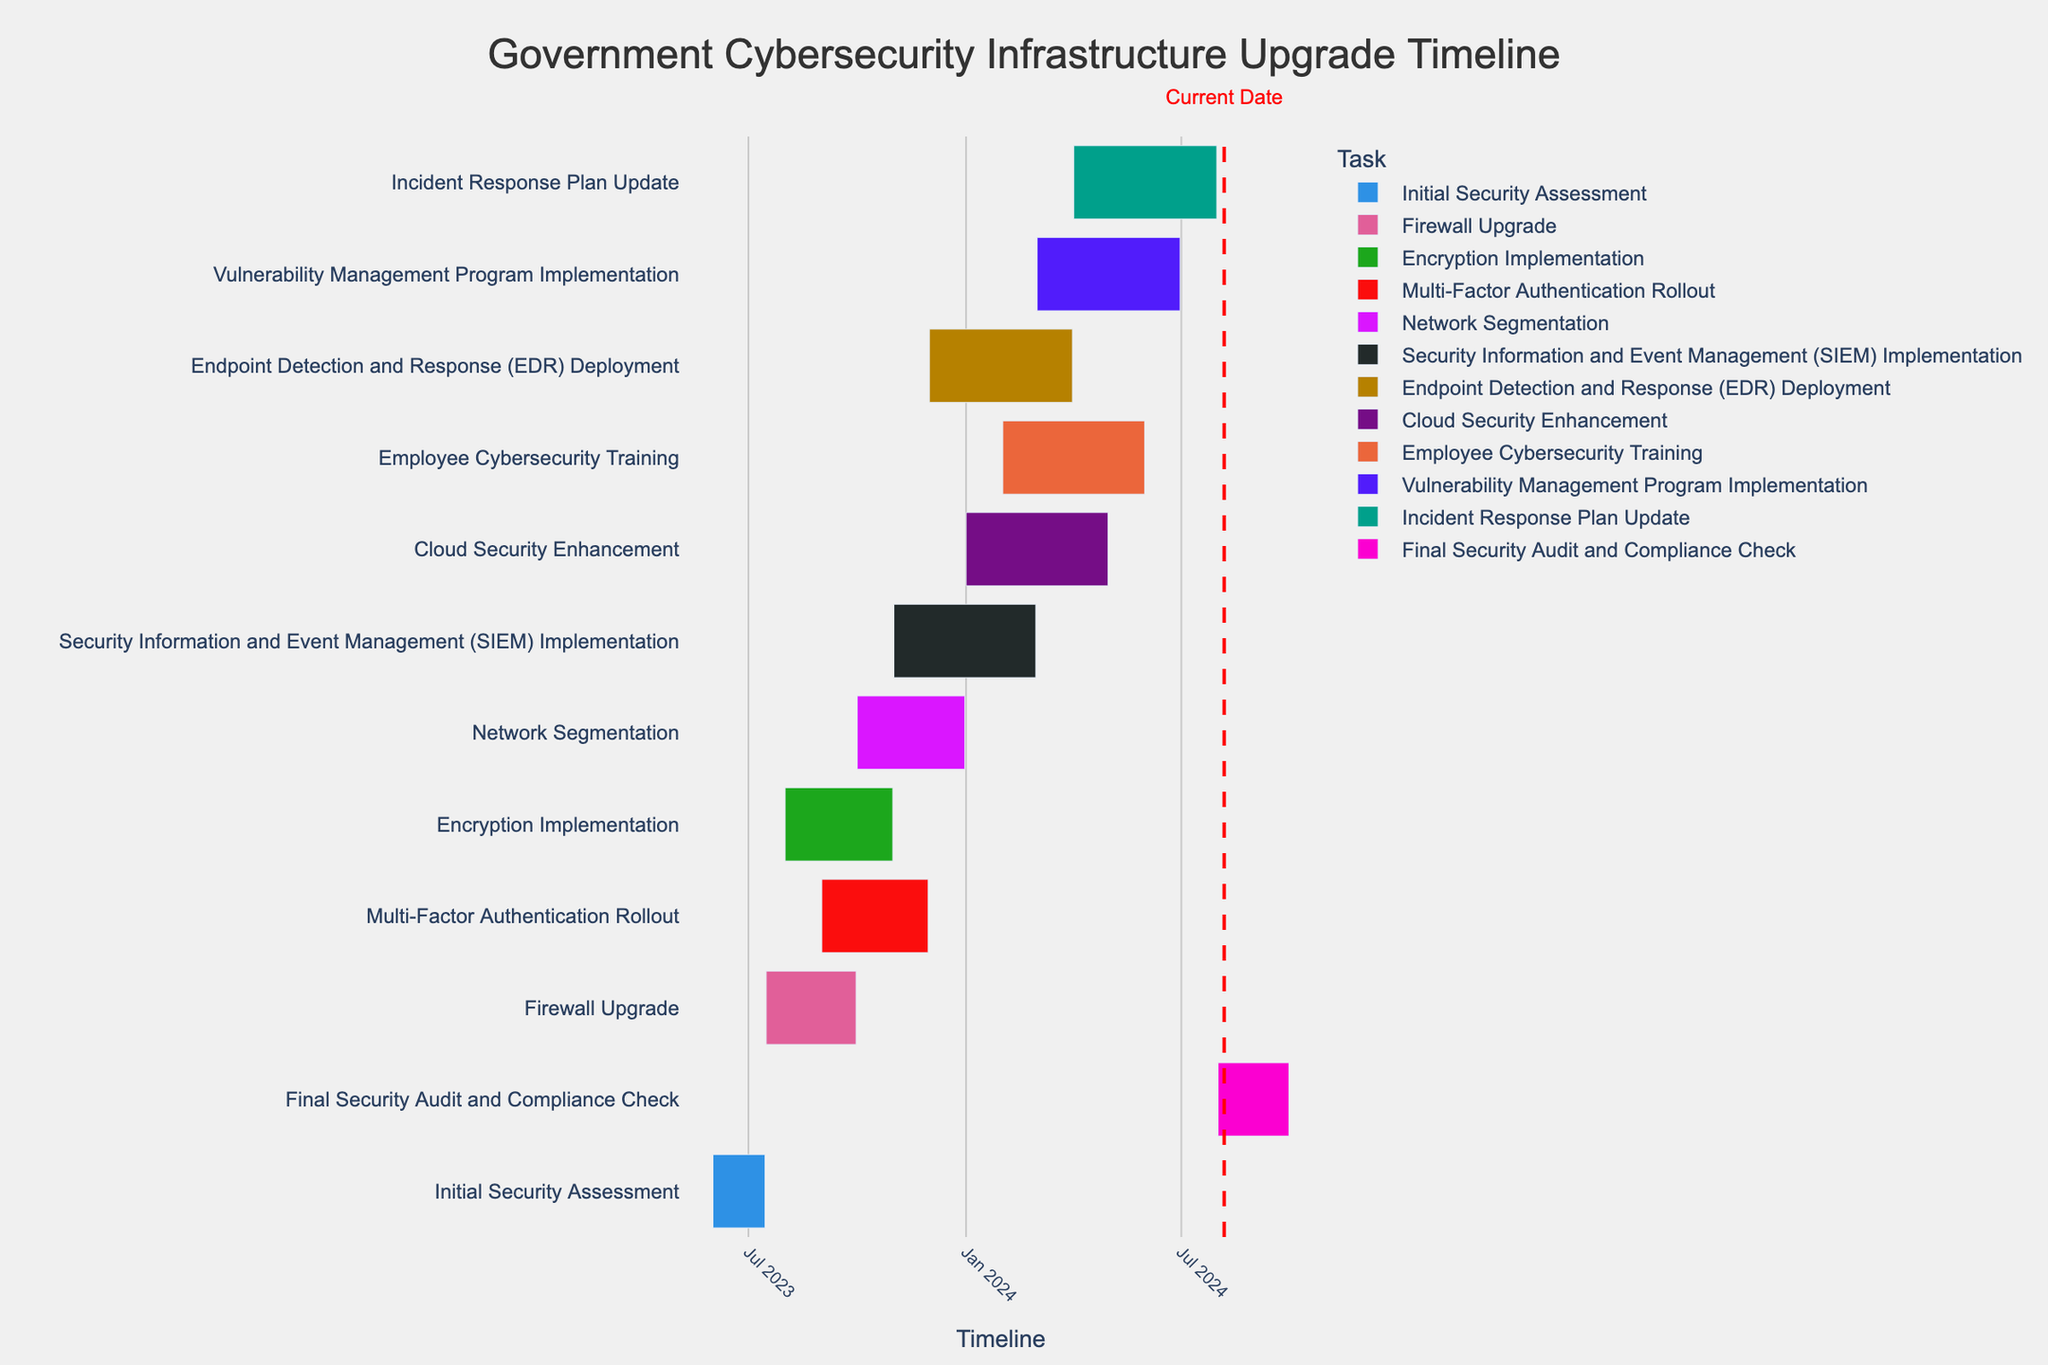When does the "Firewall Upgrade" task start and end? The "Firewall Upgrade" task starts on 2023-07-16 and ends on 2023-09-30, as shown by the timeline bars for this task.
Answer: 2023-07-16 to 2023-09-30 Which task is currently ongoing based on the current date indicated in the figure? By looking at the vertical red line representing the current date, check which task it intersects. Considering today's date is 2023-10-07, the “Network Segmentation” task is ongoing.
Answer: Network Segmentation How long is the "Encryption Implementation" task? The "Encryption Implementation" task spans from 2023-08-01 to 2023-10-31. The difference between these dates is 3 months (92 days approximately).
Answer: 3 months Which three tasks are set to start most recently after the Initial Security Assessment? After the Initial Security Assessment (ending on 2023-07-15), the tasks starting immediately are "Firewall Upgrade" (2023-07-16), "Encryption Implementation" (2023-08-01), and "Multi-Factor Authentication Rollout" (2023-09-01).
Answer: Firewall Upgrade, Encryption Implementation, Multi-Factor Authentication Rollout How many tasks are scheduled to end in February 2024? By checking the end dates in the timeline, the tasks ending in February 2024 are "Security Information and Event Management (SIEM) Implementation" on 2024-02-29 and no others.
Answer: 1 Which tasks overlap with the "Network Segmentation" task? "Network Segmentation" spans from 2023-10-01 to 2023-12-31. The overlapping tasks are "Encryption Implementation", "Multi-Factor Authentication Rollout", "Security Information and Event Management (SIEM) Implementation", and "Endpoint Detection and Response (EDR) Deployment".
Answer: Encryption Implementation, Multi-Factor Authentication Rollout, SIEM Implementation, EDR Deployment What is the last task in the timeline, and when does it end? The last task in the timeline is "Final Security Audit and Compliance Check", and it ends on 2024-09-30.
Answer: Final Security Audit and Compliance Check, 2024-09-30 Calculate the duration of the "Incident Response Plan Update" task. The "Incident Response Plan Update" spans from 2024-04-01 to 2024-07-31. The duration is about 4 months.
Answer: 4 months What is the time gap between the end of "Firewall Upgrade" and the start of "Network Segmentation"? "Firewall Upgrade" ends on 2023-09-30, and "Network Segmentation" starts on 2023-10-01. Therefore, the time gap is 1 day.
Answer: 1 day 